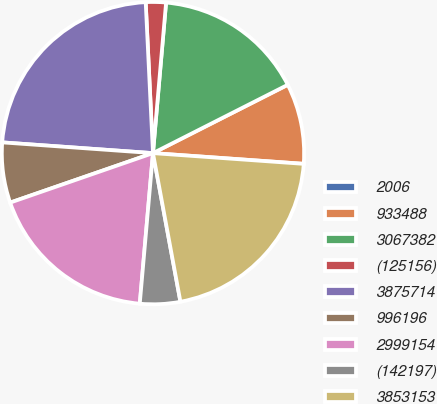<chart> <loc_0><loc_0><loc_500><loc_500><pie_chart><fcel>2006<fcel>933488<fcel>3067382<fcel>(125156)<fcel>3875714<fcel>996196<fcel>2999154<fcel>(142197)<fcel>3853153<nl><fcel>0.01%<fcel>8.59%<fcel>16.15%<fcel>2.15%<fcel>23.1%<fcel>6.44%<fcel>18.3%<fcel>4.3%<fcel>20.96%<nl></chart> 